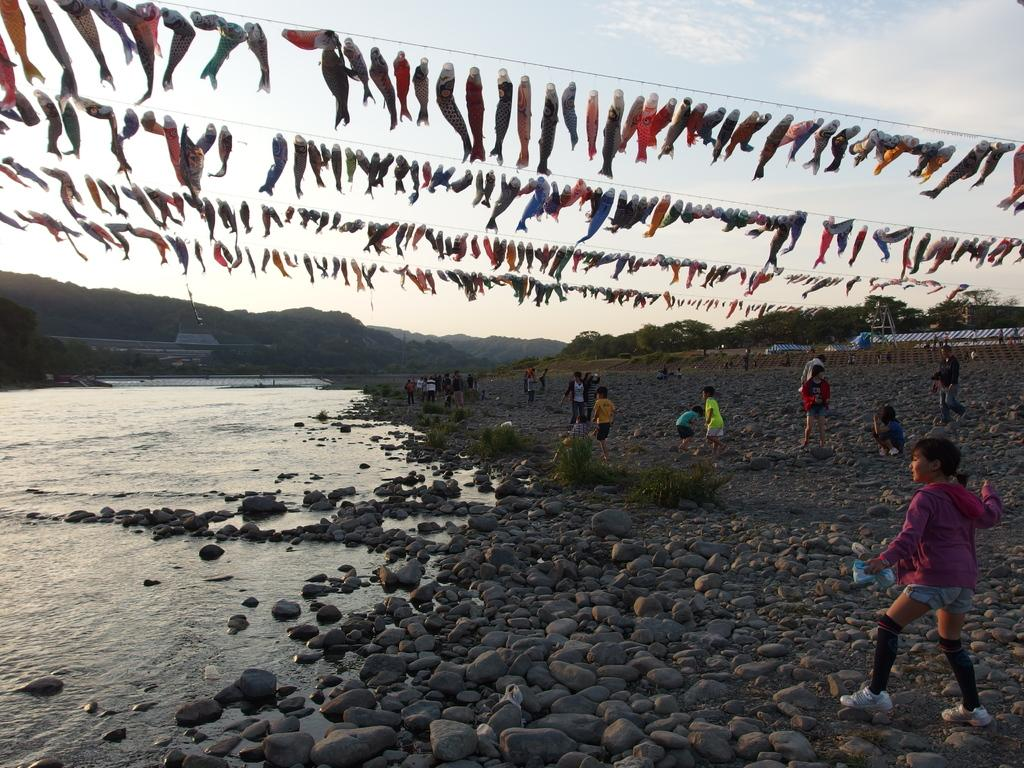What is hanging on the rope in the image? The objects hanged on the rope in the image are not specified. What type of landscape can be seen in the image? Hills, trees, and water are visible in the image, indicating a natural landscape. What is visible in the sky in the image? The sky is visible in the image, but no specific details about the sky are provided. What type of structures can be seen in the image? There are sheds in the image. What are the persons in the image doing? The persons in the image are standing on stones. What type of insect can be seen crawling on the marble in the image? There is no insect or marble present in the image. What type of badge is the person wearing in the image? There is no badge visible on any person in the image. 